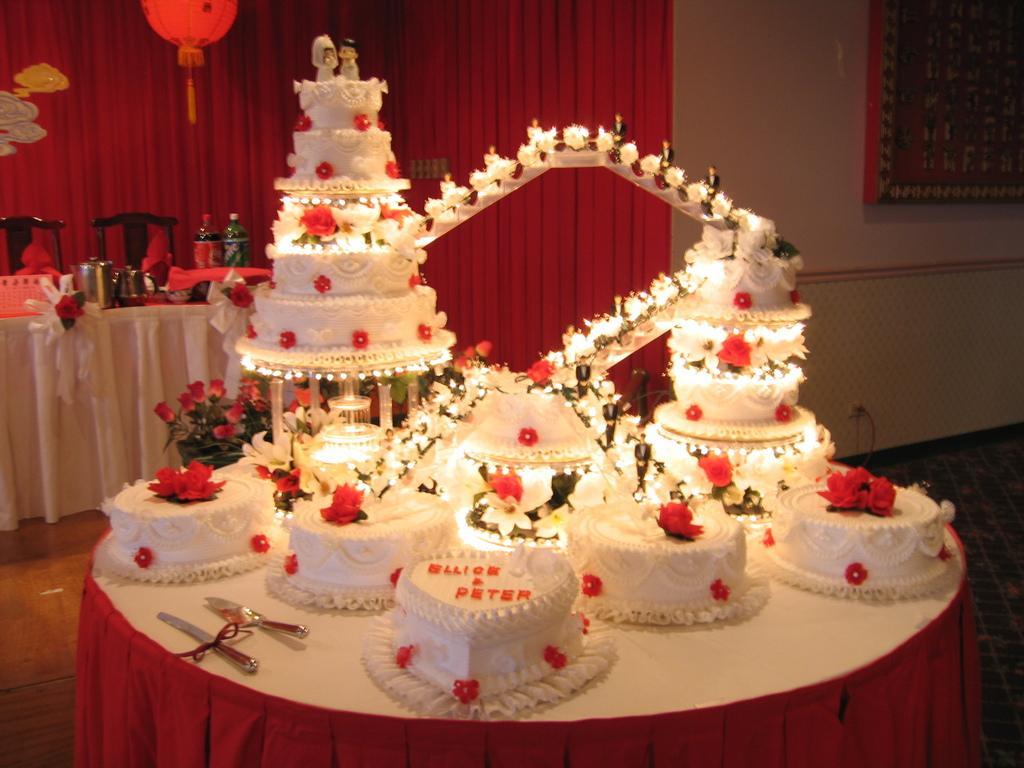Can you describe this image briefly? In the picture I can see some cakes are arranged in one table, along with the object. 